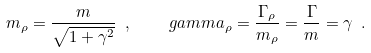<formula> <loc_0><loc_0><loc_500><loc_500>m _ { \rho } = \frac { m } { \sqrt { 1 + \gamma ^ { 2 } } } \ , \quad g a m m a _ { \rho } = \frac { \Gamma _ { \rho } } { m _ { \rho } } = \frac { \Gamma } { m } = \gamma \ .</formula> 